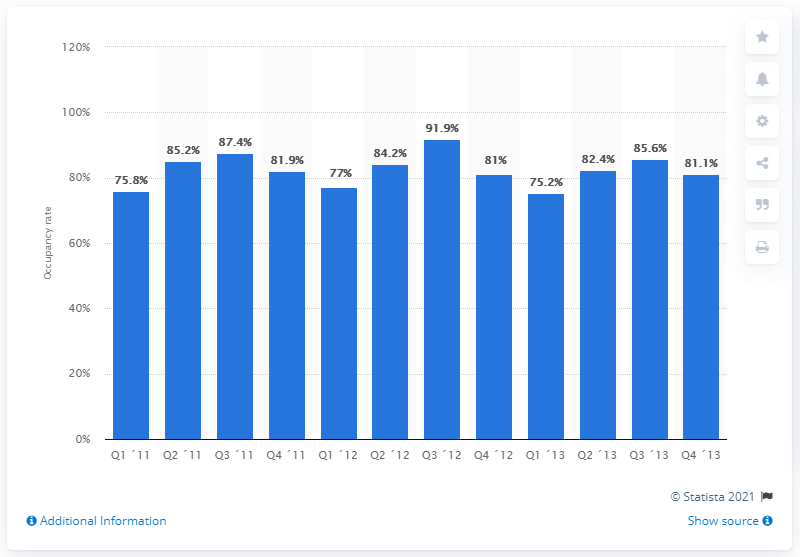Highlight a few significant elements in this photo. According to data from the first quarter of 2011, the occupancy rate of hotels in London was 75.2%. 